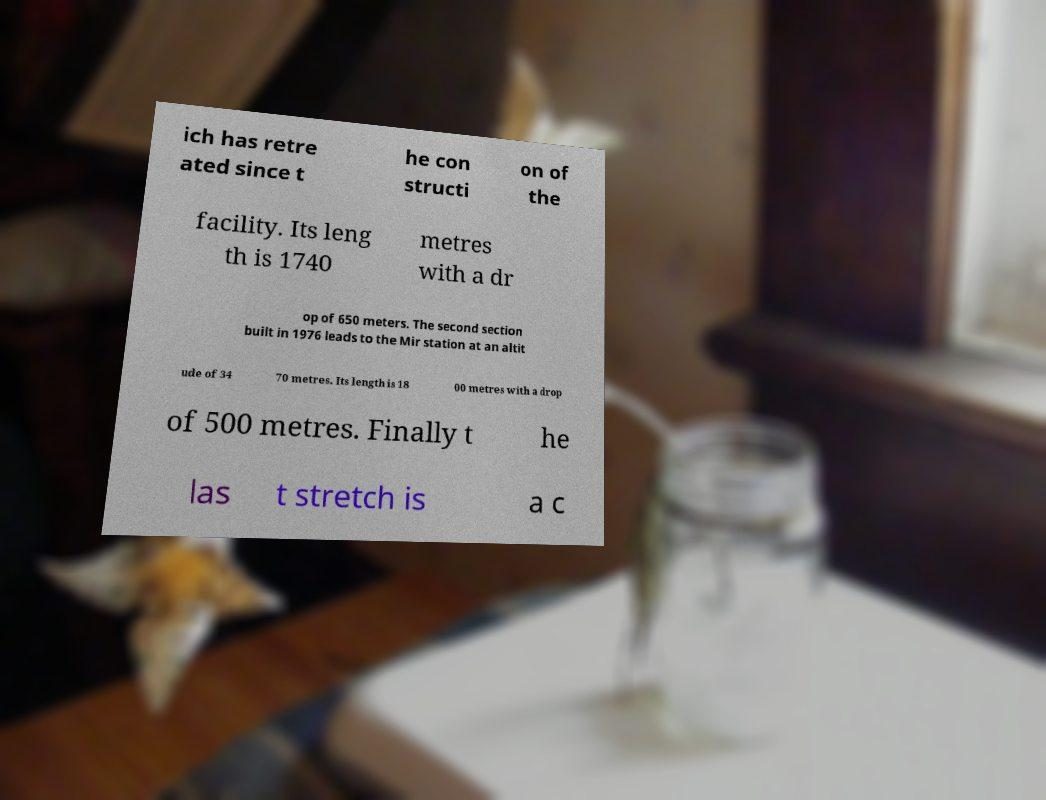Can you accurately transcribe the text from the provided image for me? ich has retre ated since t he con structi on of the facility. Its leng th is 1740 metres with a dr op of 650 meters. The second section built in 1976 leads to the Mir station at an altit ude of 34 70 metres. Its length is 18 00 metres with a drop of 500 metres. Finally t he las t stretch is a c 